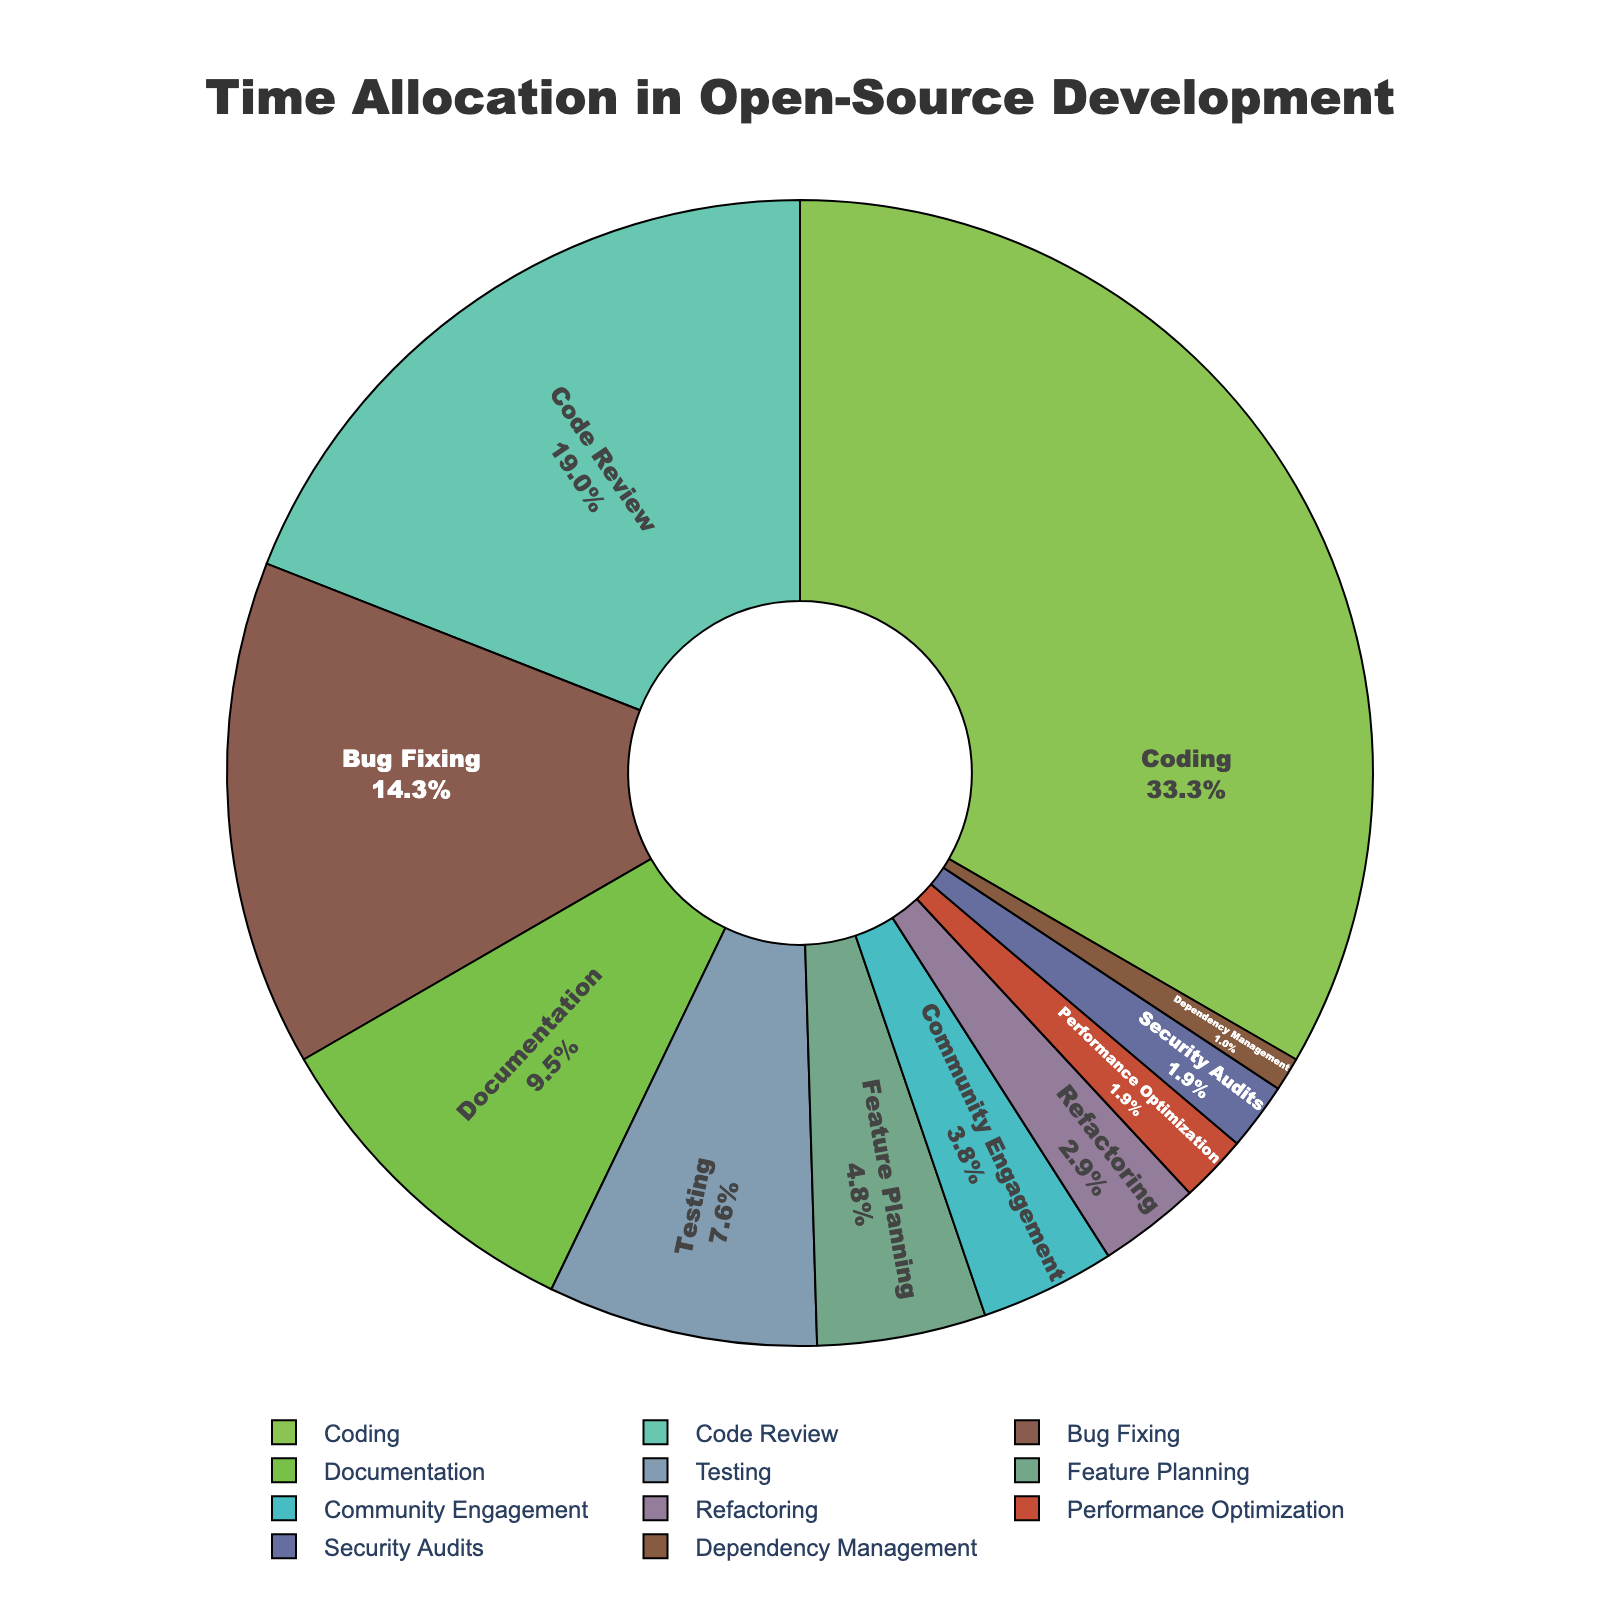Which task takes up the largest percentage of time? By looking at the pie chart, the largest segment represents the task that takes up the most time. The segment labeled "Coding" takes the largest portion.
Answer: Coding Which task takes up the least percentage of time? By examining the smallest segment of the pie chart, the task with the least time allocation can be identified. The smallest segment is labeled "Dependency Management."
Answer: Dependency Management What is the total percentage of time spent on tasks related to code quality (Code Review, Testing, Security Audits)? Add the percentages for Code Review (20%), Testing (8%) and Security Audits (2%). 20 + 8 + 2 = 30%
Answer: 30% How much more time is spent on Coding compared to Feature Planning? Subtract the percentage of time spent on Feature Planning (5%) from the percentage spent on Coding (35%). 35 - 5 = 30%
Answer: 30% Which activity takes 4% of the time? Identify the segment of the pie chart that corresponds to 4%. The segment labeled "Community Engagement" represents 4% of the total time allocation.
Answer: Community Engagement What is the sum of the percentages of Bug Fixing and Documentation? Add the percentages of Bug Fixing (15%) and Documentation (10%). 15 + 10 = 25%
Answer: 25% Is more time spent on Bug Fixing or Testing? By how much? Compare the percentages of Bug Fixing (15%) and Testing (8%), and find the difference. 15 - 8 = 7%. More time is spent on Bug Fixing by 7%.
Answer: Bug Fixing, 7% What percentage of time is spent on tasks collectively less than 5%? Sum the percentages of tasks with less than 5% time allocation: Feature Planning (5%), Community Engagement (4%), Refactoring (3%), Performance Optimization (2%), Security Audits (2%), Dependency Management (1%). 5 + 4 + 3 + 2 + 2 + 1 = 17%
Answer: 17% 